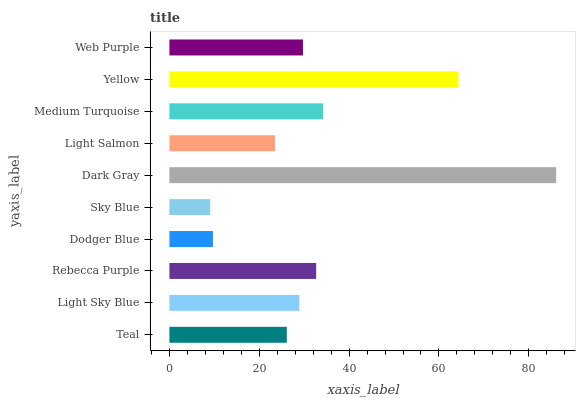Is Sky Blue the minimum?
Answer yes or no. Yes. Is Dark Gray the maximum?
Answer yes or no. Yes. Is Light Sky Blue the minimum?
Answer yes or no. No. Is Light Sky Blue the maximum?
Answer yes or no. No. Is Light Sky Blue greater than Teal?
Answer yes or no. Yes. Is Teal less than Light Sky Blue?
Answer yes or no. Yes. Is Teal greater than Light Sky Blue?
Answer yes or no. No. Is Light Sky Blue less than Teal?
Answer yes or no. No. Is Web Purple the high median?
Answer yes or no. Yes. Is Light Sky Blue the low median?
Answer yes or no. Yes. Is Sky Blue the high median?
Answer yes or no. No. Is Sky Blue the low median?
Answer yes or no. No. 